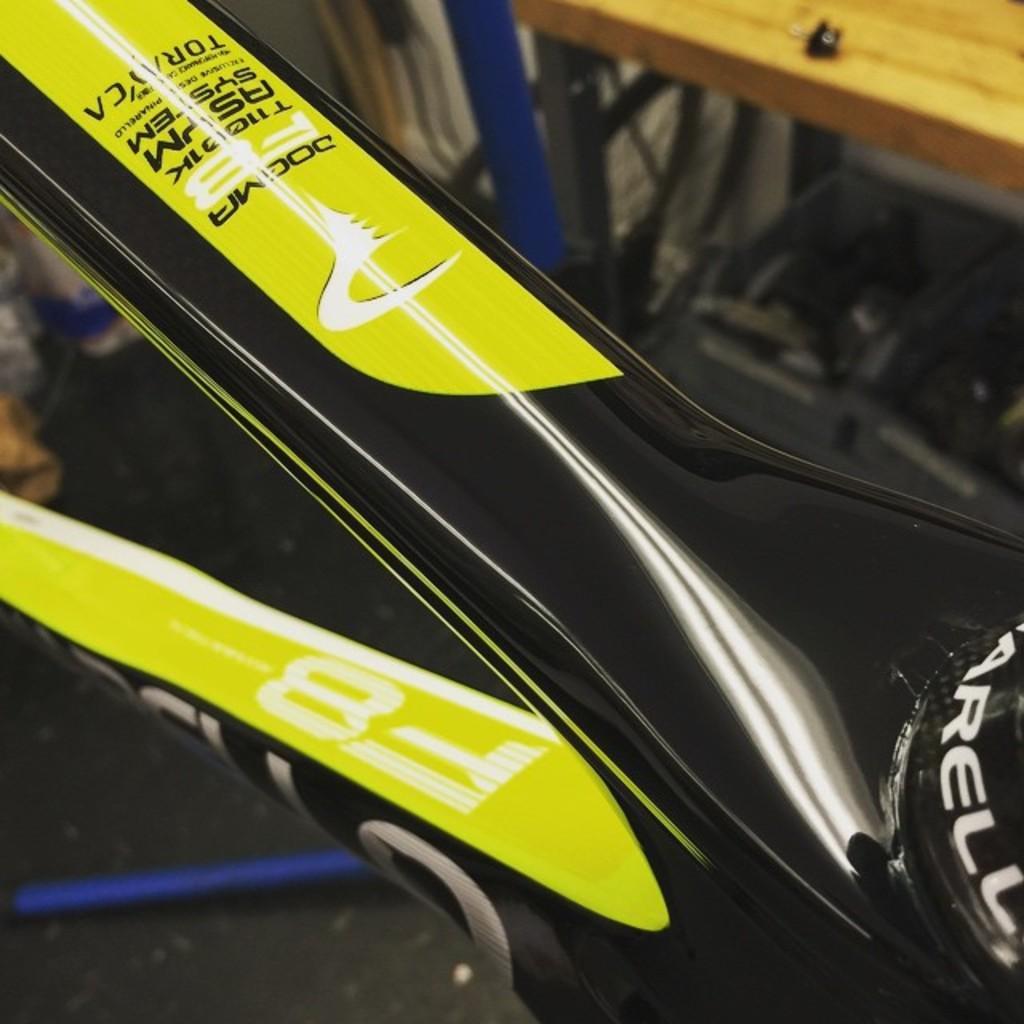Describe this image in one or two sentences. In the image we can see there are rods of a bicycle and the bicycle is kept on the ground. Behind there is a bench kept on the ground and background of the image is little blurred. 